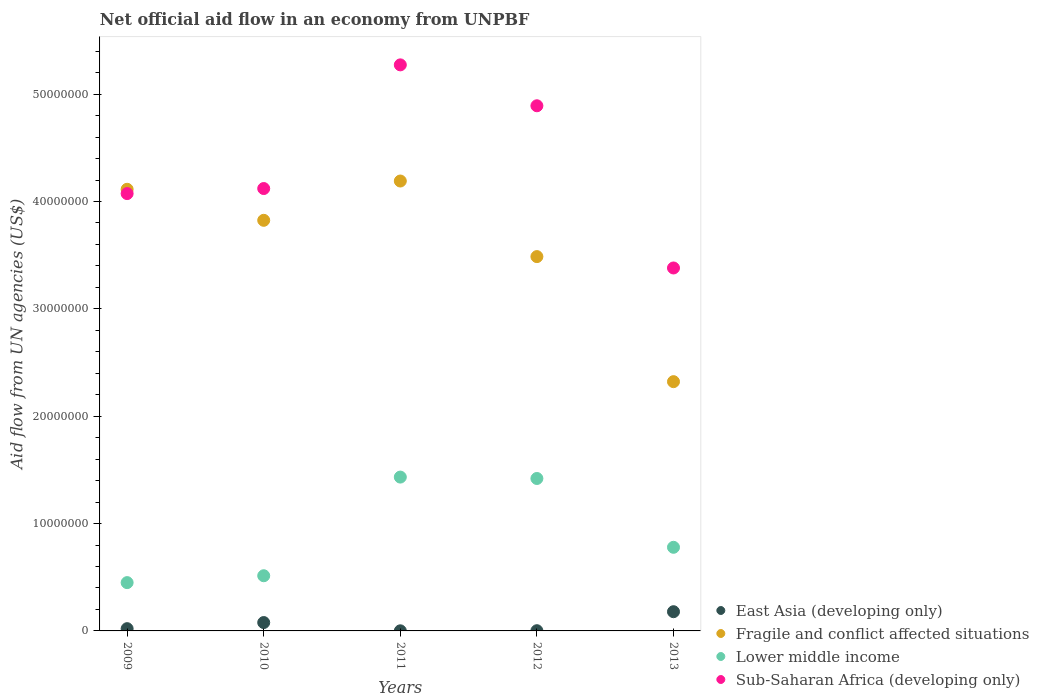How many different coloured dotlines are there?
Your answer should be very brief. 4. What is the net official aid flow in Sub-Saharan Africa (developing only) in 2011?
Your answer should be compact. 5.27e+07. Across all years, what is the maximum net official aid flow in Lower middle income?
Provide a succinct answer. 1.43e+07. Across all years, what is the minimum net official aid flow in Fragile and conflict affected situations?
Your answer should be compact. 2.32e+07. In which year was the net official aid flow in East Asia (developing only) maximum?
Offer a very short reply. 2013. In which year was the net official aid flow in Sub-Saharan Africa (developing only) minimum?
Make the answer very short. 2013. What is the total net official aid flow in Fragile and conflict affected situations in the graph?
Provide a succinct answer. 1.79e+08. What is the difference between the net official aid flow in Fragile and conflict affected situations in 2011 and that in 2013?
Give a very brief answer. 1.87e+07. What is the difference between the net official aid flow in Lower middle income in 2011 and the net official aid flow in Sub-Saharan Africa (developing only) in 2013?
Your response must be concise. -1.95e+07. What is the average net official aid flow in East Asia (developing only) per year?
Keep it short and to the point. 5.62e+05. In the year 2013, what is the difference between the net official aid flow in Fragile and conflict affected situations and net official aid flow in Lower middle income?
Provide a short and direct response. 1.54e+07. Is the difference between the net official aid flow in Fragile and conflict affected situations in 2011 and 2013 greater than the difference between the net official aid flow in Lower middle income in 2011 and 2013?
Provide a short and direct response. Yes. What is the difference between the highest and the second highest net official aid flow in Fragile and conflict affected situations?
Give a very brief answer. 7.70e+05. What is the difference between the highest and the lowest net official aid flow in East Asia (developing only)?
Provide a short and direct response. 1.78e+06. In how many years, is the net official aid flow in East Asia (developing only) greater than the average net official aid flow in East Asia (developing only) taken over all years?
Provide a succinct answer. 2. Does the net official aid flow in Lower middle income monotonically increase over the years?
Make the answer very short. No. Is the net official aid flow in East Asia (developing only) strictly greater than the net official aid flow in Fragile and conflict affected situations over the years?
Offer a very short reply. No. How many dotlines are there?
Make the answer very short. 4. How many years are there in the graph?
Keep it short and to the point. 5. What is the difference between two consecutive major ticks on the Y-axis?
Provide a succinct answer. 1.00e+07. Does the graph contain any zero values?
Your answer should be compact. No. How many legend labels are there?
Your answer should be very brief. 4. What is the title of the graph?
Keep it short and to the point. Net official aid flow in an economy from UNPBF. What is the label or title of the Y-axis?
Make the answer very short. Aid flow from UN agencies (US$). What is the Aid flow from UN agencies (US$) in East Asia (developing only) in 2009?
Give a very brief answer. 2.10e+05. What is the Aid flow from UN agencies (US$) of Fragile and conflict affected situations in 2009?
Offer a very short reply. 4.11e+07. What is the Aid flow from UN agencies (US$) in Lower middle income in 2009?
Ensure brevity in your answer.  4.50e+06. What is the Aid flow from UN agencies (US$) in Sub-Saharan Africa (developing only) in 2009?
Offer a terse response. 4.07e+07. What is the Aid flow from UN agencies (US$) of East Asia (developing only) in 2010?
Offer a very short reply. 7.80e+05. What is the Aid flow from UN agencies (US$) in Fragile and conflict affected situations in 2010?
Offer a terse response. 3.82e+07. What is the Aid flow from UN agencies (US$) of Lower middle income in 2010?
Provide a succinct answer. 5.14e+06. What is the Aid flow from UN agencies (US$) of Sub-Saharan Africa (developing only) in 2010?
Make the answer very short. 4.12e+07. What is the Aid flow from UN agencies (US$) in Fragile and conflict affected situations in 2011?
Provide a succinct answer. 4.19e+07. What is the Aid flow from UN agencies (US$) in Lower middle income in 2011?
Ensure brevity in your answer.  1.43e+07. What is the Aid flow from UN agencies (US$) of Sub-Saharan Africa (developing only) in 2011?
Give a very brief answer. 5.27e+07. What is the Aid flow from UN agencies (US$) of East Asia (developing only) in 2012?
Your answer should be compact. 2.00e+04. What is the Aid flow from UN agencies (US$) of Fragile and conflict affected situations in 2012?
Provide a succinct answer. 3.49e+07. What is the Aid flow from UN agencies (US$) in Lower middle income in 2012?
Offer a terse response. 1.42e+07. What is the Aid flow from UN agencies (US$) of Sub-Saharan Africa (developing only) in 2012?
Make the answer very short. 4.89e+07. What is the Aid flow from UN agencies (US$) of East Asia (developing only) in 2013?
Give a very brief answer. 1.79e+06. What is the Aid flow from UN agencies (US$) of Fragile and conflict affected situations in 2013?
Provide a short and direct response. 2.32e+07. What is the Aid flow from UN agencies (US$) of Lower middle income in 2013?
Your answer should be very brief. 7.79e+06. What is the Aid flow from UN agencies (US$) of Sub-Saharan Africa (developing only) in 2013?
Offer a very short reply. 3.38e+07. Across all years, what is the maximum Aid flow from UN agencies (US$) of East Asia (developing only)?
Your answer should be compact. 1.79e+06. Across all years, what is the maximum Aid flow from UN agencies (US$) of Fragile and conflict affected situations?
Your answer should be very brief. 4.19e+07. Across all years, what is the maximum Aid flow from UN agencies (US$) in Lower middle income?
Your answer should be compact. 1.43e+07. Across all years, what is the maximum Aid flow from UN agencies (US$) of Sub-Saharan Africa (developing only)?
Ensure brevity in your answer.  5.27e+07. Across all years, what is the minimum Aid flow from UN agencies (US$) in East Asia (developing only)?
Offer a terse response. 10000. Across all years, what is the minimum Aid flow from UN agencies (US$) of Fragile and conflict affected situations?
Make the answer very short. 2.32e+07. Across all years, what is the minimum Aid flow from UN agencies (US$) of Lower middle income?
Ensure brevity in your answer.  4.50e+06. Across all years, what is the minimum Aid flow from UN agencies (US$) of Sub-Saharan Africa (developing only)?
Provide a succinct answer. 3.38e+07. What is the total Aid flow from UN agencies (US$) in East Asia (developing only) in the graph?
Your answer should be very brief. 2.81e+06. What is the total Aid flow from UN agencies (US$) in Fragile and conflict affected situations in the graph?
Ensure brevity in your answer.  1.79e+08. What is the total Aid flow from UN agencies (US$) in Lower middle income in the graph?
Offer a very short reply. 4.60e+07. What is the total Aid flow from UN agencies (US$) of Sub-Saharan Africa (developing only) in the graph?
Make the answer very short. 2.17e+08. What is the difference between the Aid flow from UN agencies (US$) in East Asia (developing only) in 2009 and that in 2010?
Offer a very short reply. -5.70e+05. What is the difference between the Aid flow from UN agencies (US$) in Fragile and conflict affected situations in 2009 and that in 2010?
Your answer should be compact. 2.89e+06. What is the difference between the Aid flow from UN agencies (US$) of Lower middle income in 2009 and that in 2010?
Ensure brevity in your answer.  -6.40e+05. What is the difference between the Aid flow from UN agencies (US$) in Sub-Saharan Africa (developing only) in 2009 and that in 2010?
Your response must be concise. -4.70e+05. What is the difference between the Aid flow from UN agencies (US$) of Fragile and conflict affected situations in 2009 and that in 2011?
Your response must be concise. -7.70e+05. What is the difference between the Aid flow from UN agencies (US$) in Lower middle income in 2009 and that in 2011?
Provide a short and direct response. -9.83e+06. What is the difference between the Aid flow from UN agencies (US$) of Sub-Saharan Africa (developing only) in 2009 and that in 2011?
Provide a short and direct response. -1.20e+07. What is the difference between the Aid flow from UN agencies (US$) of East Asia (developing only) in 2009 and that in 2012?
Your answer should be compact. 1.90e+05. What is the difference between the Aid flow from UN agencies (US$) in Fragile and conflict affected situations in 2009 and that in 2012?
Make the answer very short. 6.27e+06. What is the difference between the Aid flow from UN agencies (US$) of Lower middle income in 2009 and that in 2012?
Keep it short and to the point. -9.70e+06. What is the difference between the Aid flow from UN agencies (US$) of Sub-Saharan Africa (developing only) in 2009 and that in 2012?
Offer a terse response. -8.18e+06. What is the difference between the Aid flow from UN agencies (US$) in East Asia (developing only) in 2009 and that in 2013?
Your answer should be very brief. -1.58e+06. What is the difference between the Aid flow from UN agencies (US$) in Fragile and conflict affected situations in 2009 and that in 2013?
Your response must be concise. 1.79e+07. What is the difference between the Aid flow from UN agencies (US$) in Lower middle income in 2009 and that in 2013?
Provide a succinct answer. -3.29e+06. What is the difference between the Aid flow from UN agencies (US$) in Sub-Saharan Africa (developing only) in 2009 and that in 2013?
Offer a very short reply. 6.93e+06. What is the difference between the Aid flow from UN agencies (US$) of East Asia (developing only) in 2010 and that in 2011?
Offer a terse response. 7.70e+05. What is the difference between the Aid flow from UN agencies (US$) of Fragile and conflict affected situations in 2010 and that in 2011?
Your response must be concise. -3.66e+06. What is the difference between the Aid flow from UN agencies (US$) in Lower middle income in 2010 and that in 2011?
Keep it short and to the point. -9.19e+06. What is the difference between the Aid flow from UN agencies (US$) in Sub-Saharan Africa (developing only) in 2010 and that in 2011?
Make the answer very short. -1.15e+07. What is the difference between the Aid flow from UN agencies (US$) in East Asia (developing only) in 2010 and that in 2012?
Make the answer very short. 7.60e+05. What is the difference between the Aid flow from UN agencies (US$) of Fragile and conflict affected situations in 2010 and that in 2012?
Give a very brief answer. 3.38e+06. What is the difference between the Aid flow from UN agencies (US$) of Lower middle income in 2010 and that in 2012?
Your answer should be compact. -9.06e+06. What is the difference between the Aid flow from UN agencies (US$) in Sub-Saharan Africa (developing only) in 2010 and that in 2012?
Keep it short and to the point. -7.71e+06. What is the difference between the Aid flow from UN agencies (US$) of East Asia (developing only) in 2010 and that in 2013?
Make the answer very short. -1.01e+06. What is the difference between the Aid flow from UN agencies (US$) in Fragile and conflict affected situations in 2010 and that in 2013?
Offer a terse response. 1.50e+07. What is the difference between the Aid flow from UN agencies (US$) in Lower middle income in 2010 and that in 2013?
Your answer should be compact. -2.65e+06. What is the difference between the Aid flow from UN agencies (US$) in Sub-Saharan Africa (developing only) in 2010 and that in 2013?
Your response must be concise. 7.40e+06. What is the difference between the Aid flow from UN agencies (US$) in East Asia (developing only) in 2011 and that in 2012?
Your answer should be compact. -10000. What is the difference between the Aid flow from UN agencies (US$) in Fragile and conflict affected situations in 2011 and that in 2012?
Give a very brief answer. 7.04e+06. What is the difference between the Aid flow from UN agencies (US$) of Sub-Saharan Africa (developing only) in 2011 and that in 2012?
Offer a very short reply. 3.81e+06. What is the difference between the Aid flow from UN agencies (US$) of East Asia (developing only) in 2011 and that in 2013?
Your answer should be compact. -1.78e+06. What is the difference between the Aid flow from UN agencies (US$) of Fragile and conflict affected situations in 2011 and that in 2013?
Make the answer very short. 1.87e+07. What is the difference between the Aid flow from UN agencies (US$) of Lower middle income in 2011 and that in 2013?
Your answer should be compact. 6.54e+06. What is the difference between the Aid flow from UN agencies (US$) of Sub-Saharan Africa (developing only) in 2011 and that in 2013?
Give a very brief answer. 1.89e+07. What is the difference between the Aid flow from UN agencies (US$) in East Asia (developing only) in 2012 and that in 2013?
Keep it short and to the point. -1.77e+06. What is the difference between the Aid flow from UN agencies (US$) in Fragile and conflict affected situations in 2012 and that in 2013?
Provide a succinct answer. 1.16e+07. What is the difference between the Aid flow from UN agencies (US$) in Lower middle income in 2012 and that in 2013?
Your answer should be compact. 6.41e+06. What is the difference between the Aid flow from UN agencies (US$) of Sub-Saharan Africa (developing only) in 2012 and that in 2013?
Your answer should be compact. 1.51e+07. What is the difference between the Aid flow from UN agencies (US$) of East Asia (developing only) in 2009 and the Aid flow from UN agencies (US$) of Fragile and conflict affected situations in 2010?
Give a very brief answer. -3.80e+07. What is the difference between the Aid flow from UN agencies (US$) in East Asia (developing only) in 2009 and the Aid flow from UN agencies (US$) in Lower middle income in 2010?
Make the answer very short. -4.93e+06. What is the difference between the Aid flow from UN agencies (US$) of East Asia (developing only) in 2009 and the Aid flow from UN agencies (US$) of Sub-Saharan Africa (developing only) in 2010?
Make the answer very short. -4.10e+07. What is the difference between the Aid flow from UN agencies (US$) of Fragile and conflict affected situations in 2009 and the Aid flow from UN agencies (US$) of Lower middle income in 2010?
Offer a terse response. 3.60e+07. What is the difference between the Aid flow from UN agencies (US$) of Fragile and conflict affected situations in 2009 and the Aid flow from UN agencies (US$) of Sub-Saharan Africa (developing only) in 2010?
Provide a short and direct response. -7.00e+04. What is the difference between the Aid flow from UN agencies (US$) in Lower middle income in 2009 and the Aid flow from UN agencies (US$) in Sub-Saharan Africa (developing only) in 2010?
Make the answer very short. -3.67e+07. What is the difference between the Aid flow from UN agencies (US$) in East Asia (developing only) in 2009 and the Aid flow from UN agencies (US$) in Fragile and conflict affected situations in 2011?
Your answer should be very brief. -4.17e+07. What is the difference between the Aid flow from UN agencies (US$) in East Asia (developing only) in 2009 and the Aid flow from UN agencies (US$) in Lower middle income in 2011?
Give a very brief answer. -1.41e+07. What is the difference between the Aid flow from UN agencies (US$) in East Asia (developing only) in 2009 and the Aid flow from UN agencies (US$) in Sub-Saharan Africa (developing only) in 2011?
Offer a terse response. -5.25e+07. What is the difference between the Aid flow from UN agencies (US$) of Fragile and conflict affected situations in 2009 and the Aid flow from UN agencies (US$) of Lower middle income in 2011?
Make the answer very short. 2.68e+07. What is the difference between the Aid flow from UN agencies (US$) of Fragile and conflict affected situations in 2009 and the Aid flow from UN agencies (US$) of Sub-Saharan Africa (developing only) in 2011?
Your answer should be compact. -1.16e+07. What is the difference between the Aid flow from UN agencies (US$) of Lower middle income in 2009 and the Aid flow from UN agencies (US$) of Sub-Saharan Africa (developing only) in 2011?
Give a very brief answer. -4.82e+07. What is the difference between the Aid flow from UN agencies (US$) in East Asia (developing only) in 2009 and the Aid flow from UN agencies (US$) in Fragile and conflict affected situations in 2012?
Provide a short and direct response. -3.47e+07. What is the difference between the Aid flow from UN agencies (US$) of East Asia (developing only) in 2009 and the Aid flow from UN agencies (US$) of Lower middle income in 2012?
Ensure brevity in your answer.  -1.40e+07. What is the difference between the Aid flow from UN agencies (US$) in East Asia (developing only) in 2009 and the Aid flow from UN agencies (US$) in Sub-Saharan Africa (developing only) in 2012?
Your answer should be very brief. -4.87e+07. What is the difference between the Aid flow from UN agencies (US$) in Fragile and conflict affected situations in 2009 and the Aid flow from UN agencies (US$) in Lower middle income in 2012?
Offer a terse response. 2.69e+07. What is the difference between the Aid flow from UN agencies (US$) in Fragile and conflict affected situations in 2009 and the Aid flow from UN agencies (US$) in Sub-Saharan Africa (developing only) in 2012?
Offer a very short reply. -7.78e+06. What is the difference between the Aid flow from UN agencies (US$) of Lower middle income in 2009 and the Aid flow from UN agencies (US$) of Sub-Saharan Africa (developing only) in 2012?
Make the answer very short. -4.44e+07. What is the difference between the Aid flow from UN agencies (US$) in East Asia (developing only) in 2009 and the Aid flow from UN agencies (US$) in Fragile and conflict affected situations in 2013?
Your answer should be compact. -2.30e+07. What is the difference between the Aid flow from UN agencies (US$) in East Asia (developing only) in 2009 and the Aid flow from UN agencies (US$) in Lower middle income in 2013?
Provide a short and direct response. -7.58e+06. What is the difference between the Aid flow from UN agencies (US$) in East Asia (developing only) in 2009 and the Aid flow from UN agencies (US$) in Sub-Saharan Africa (developing only) in 2013?
Offer a very short reply. -3.36e+07. What is the difference between the Aid flow from UN agencies (US$) in Fragile and conflict affected situations in 2009 and the Aid flow from UN agencies (US$) in Lower middle income in 2013?
Offer a terse response. 3.34e+07. What is the difference between the Aid flow from UN agencies (US$) of Fragile and conflict affected situations in 2009 and the Aid flow from UN agencies (US$) of Sub-Saharan Africa (developing only) in 2013?
Ensure brevity in your answer.  7.33e+06. What is the difference between the Aid flow from UN agencies (US$) of Lower middle income in 2009 and the Aid flow from UN agencies (US$) of Sub-Saharan Africa (developing only) in 2013?
Keep it short and to the point. -2.93e+07. What is the difference between the Aid flow from UN agencies (US$) of East Asia (developing only) in 2010 and the Aid flow from UN agencies (US$) of Fragile and conflict affected situations in 2011?
Keep it short and to the point. -4.11e+07. What is the difference between the Aid flow from UN agencies (US$) of East Asia (developing only) in 2010 and the Aid flow from UN agencies (US$) of Lower middle income in 2011?
Offer a very short reply. -1.36e+07. What is the difference between the Aid flow from UN agencies (US$) of East Asia (developing only) in 2010 and the Aid flow from UN agencies (US$) of Sub-Saharan Africa (developing only) in 2011?
Your answer should be very brief. -5.20e+07. What is the difference between the Aid flow from UN agencies (US$) in Fragile and conflict affected situations in 2010 and the Aid flow from UN agencies (US$) in Lower middle income in 2011?
Give a very brief answer. 2.39e+07. What is the difference between the Aid flow from UN agencies (US$) of Fragile and conflict affected situations in 2010 and the Aid flow from UN agencies (US$) of Sub-Saharan Africa (developing only) in 2011?
Give a very brief answer. -1.45e+07. What is the difference between the Aid flow from UN agencies (US$) in Lower middle income in 2010 and the Aid flow from UN agencies (US$) in Sub-Saharan Africa (developing only) in 2011?
Give a very brief answer. -4.76e+07. What is the difference between the Aid flow from UN agencies (US$) of East Asia (developing only) in 2010 and the Aid flow from UN agencies (US$) of Fragile and conflict affected situations in 2012?
Your answer should be compact. -3.41e+07. What is the difference between the Aid flow from UN agencies (US$) of East Asia (developing only) in 2010 and the Aid flow from UN agencies (US$) of Lower middle income in 2012?
Offer a terse response. -1.34e+07. What is the difference between the Aid flow from UN agencies (US$) of East Asia (developing only) in 2010 and the Aid flow from UN agencies (US$) of Sub-Saharan Africa (developing only) in 2012?
Ensure brevity in your answer.  -4.81e+07. What is the difference between the Aid flow from UN agencies (US$) in Fragile and conflict affected situations in 2010 and the Aid flow from UN agencies (US$) in Lower middle income in 2012?
Offer a terse response. 2.40e+07. What is the difference between the Aid flow from UN agencies (US$) of Fragile and conflict affected situations in 2010 and the Aid flow from UN agencies (US$) of Sub-Saharan Africa (developing only) in 2012?
Provide a succinct answer. -1.07e+07. What is the difference between the Aid flow from UN agencies (US$) in Lower middle income in 2010 and the Aid flow from UN agencies (US$) in Sub-Saharan Africa (developing only) in 2012?
Your answer should be very brief. -4.38e+07. What is the difference between the Aid flow from UN agencies (US$) of East Asia (developing only) in 2010 and the Aid flow from UN agencies (US$) of Fragile and conflict affected situations in 2013?
Offer a terse response. -2.24e+07. What is the difference between the Aid flow from UN agencies (US$) in East Asia (developing only) in 2010 and the Aid flow from UN agencies (US$) in Lower middle income in 2013?
Your answer should be very brief. -7.01e+06. What is the difference between the Aid flow from UN agencies (US$) in East Asia (developing only) in 2010 and the Aid flow from UN agencies (US$) in Sub-Saharan Africa (developing only) in 2013?
Keep it short and to the point. -3.30e+07. What is the difference between the Aid flow from UN agencies (US$) in Fragile and conflict affected situations in 2010 and the Aid flow from UN agencies (US$) in Lower middle income in 2013?
Your response must be concise. 3.05e+07. What is the difference between the Aid flow from UN agencies (US$) of Fragile and conflict affected situations in 2010 and the Aid flow from UN agencies (US$) of Sub-Saharan Africa (developing only) in 2013?
Offer a very short reply. 4.44e+06. What is the difference between the Aid flow from UN agencies (US$) of Lower middle income in 2010 and the Aid flow from UN agencies (US$) of Sub-Saharan Africa (developing only) in 2013?
Make the answer very short. -2.87e+07. What is the difference between the Aid flow from UN agencies (US$) in East Asia (developing only) in 2011 and the Aid flow from UN agencies (US$) in Fragile and conflict affected situations in 2012?
Offer a very short reply. -3.49e+07. What is the difference between the Aid flow from UN agencies (US$) of East Asia (developing only) in 2011 and the Aid flow from UN agencies (US$) of Lower middle income in 2012?
Offer a terse response. -1.42e+07. What is the difference between the Aid flow from UN agencies (US$) in East Asia (developing only) in 2011 and the Aid flow from UN agencies (US$) in Sub-Saharan Africa (developing only) in 2012?
Offer a terse response. -4.89e+07. What is the difference between the Aid flow from UN agencies (US$) in Fragile and conflict affected situations in 2011 and the Aid flow from UN agencies (US$) in Lower middle income in 2012?
Offer a very short reply. 2.77e+07. What is the difference between the Aid flow from UN agencies (US$) of Fragile and conflict affected situations in 2011 and the Aid flow from UN agencies (US$) of Sub-Saharan Africa (developing only) in 2012?
Offer a very short reply. -7.01e+06. What is the difference between the Aid flow from UN agencies (US$) in Lower middle income in 2011 and the Aid flow from UN agencies (US$) in Sub-Saharan Africa (developing only) in 2012?
Your response must be concise. -3.46e+07. What is the difference between the Aid flow from UN agencies (US$) in East Asia (developing only) in 2011 and the Aid flow from UN agencies (US$) in Fragile and conflict affected situations in 2013?
Your answer should be very brief. -2.32e+07. What is the difference between the Aid flow from UN agencies (US$) in East Asia (developing only) in 2011 and the Aid flow from UN agencies (US$) in Lower middle income in 2013?
Give a very brief answer. -7.78e+06. What is the difference between the Aid flow from UN agencies (US$) in East Asia (developing only) in 2011 and the Aid flow from UN agencies (US$) in Sub-Saharan Africa (developing only) in 2013?
Offer a very short reply. -3.38e+07. What is the difference between the Aid flow from UN agencies (US$) of Fragile and conflict affected situations in 2011 and the Aid flow from UN agencies (US$) of Lower middle income in 2013?
Ensure brevity in your answer.  3.41e+07. What is the difference between the Aid flow from UN agencies (US$) in Fragile and conflict affected situations in 2011 and the Aid flow from UN agencies (US$) in Sub-Saharan Africa (developing only) in 2013?
Offer a very short reply. 8.10e+06. What is the difference between the Aid flow from UN agencies (US$) in Lower middle income in 2011 and the Aid flow from UN agencies (US$) in Sub-Saharan Africa (developing only) in 2013?
Offer a terse response. -1.95e+07. What is the difference between the Aid flow from UN agencies (US$) of East Asia (developing only) in 2012 and the Aid flow from UN agencies (US$) of Fragile and conflict affected situations in 2013?
Provide a succinct answer. -2.32e+07. What is the difference between the Aid flow from UN agencies (US$) of East Asia (developing only) in 2012 and the Aid flow from UN agencies (US$) of Lower middle income in 2013?
Provide a succinct answer. -7.77e+06. What is the difference between the Aid flow from UN agencies (US$) in East Asia (developing only) in 2012 and the Aid flow from UN agencies (US$) in Sub-Saharan Africa (developing only) in 2013?
Give a very brief answer. -3.38e+07. What is the difference between the Aid flow from UN agencies (US$) of Fragile and conflict affected situations in 2012 and the Aid flow from UN agencies (US$) of Lower middle income in 2013?
Your answer should be very brief. 2.71e+07. What is the difference between the Aid flow from UN agencies (US$) of Fragile and conflict affected situations in 2012 and the Aid flow from UN agencies (US$) of Sub-Saharan Africa (developing only) in 2013?
Make the answer very short. 1.06e+06. What is the difference between the Aid flow from UN agencies (US$) of Lower middle income in 2012 and the Aid flow from UN agencies (US$) of Sub-Saharan Africa (developing only) in 2013?
Offer a very short reply. -1.96e+07. What is the average Aid flow from UN agencies (US$) of East Asia (developing only) per year?
Provide a succinct answer. 5.62e+05. What is the average Aid flow from UN agencies (US$) of Fragile and conflict affected situations per year?
Your answer should be compact. 3.59e+07. What is the average Aid flow from UN agencies (US$) of Lower middle income per year?
Provide a short and direct response. 9.19e+06. What is the average Aid flow from UN agencies (US$) in Sub-Saharan Africa (developing only) per year?
Give a very brief answer. 4.35e+07. In the year 2009, what is the difference between the Aid flow from UN agencies (US$) in East Asia (developing only) and Aid flow from UN agencies (US$) in Fragile and conflict affected situations?
Offer a very short reply. -4.09e+07. In the year 2009, what is the difference between the Aid flow from UN agencies (US$) of East Asia (developing only) and Aid flow from UN agencies (US$) of Lower middle income?
Provide a short and direct response. -4.29e+06. In the year 2009, what is the difference between the Aid flow from UN agencies (US$) in East Asia (developing only) and Aid flow from UN agencies (US$) in Sub-Saharan Africa (developing only)?
Give a very brief answer. -4.05e+07. In the year 2009, what is the difference between the Aid flow from UN agencies (US$) of Fragile and conflict affected situations and Aid flow from UN agencies (US$) of Lower middle income?
Provide a short and direct response. 3.66e+07. In the year 2009, what is the difference between the Aid flow from UN agencies (US$) of Fragile and conflict affected situations and Aid flow from UN agencies (US$) of Sub-Saharan Africa (developing only)?
Make the answer very short. 4.00e+05. In the year 2009, what is the difference between the Aid flow from UN agencies (US$) in Lower middle income and Aid flow from UN agencies (US$) in Sub-Saharan Africa (developing only)?
Your answer should be very brief. -3.62e+07. In the year 2010, what is the difference between the Aid flow from UN agencies (US$) of East Asia (developing only) and Aid flow from UN agencies (US$) of Fragile and conflict affected situations?
Provide a succinct answer. -3.75e+07. In the year 2010, what is the difference between the Aid flow from UN agencies (US$) of East Asia (developing only) and Aid flow from UN agencies (US$) of Lower middle income?
Give a very brief answer. -4.36e+06. In the year 2010, what is the difference between the Aid flow from UN agencies (US$) in East Asia (developing only) and Aid flow from UN agencies (US$) in Sub-Saharan Africa (developing only)?
Keep it short and to the point. -4.04e+07. In the year 2010, what is the difference between the Aid flow from UN agencies (US$) in Fragile and conflict affected situations and Aid flow from UN agencies (US$) in Lower middle income?
Your answer should be very brief. 3.31e+07. In the year 2010, what is the difference between the Aid flow from UN agencies (US$) of Fragile and conflict affected situations and Aid flow from UN agencies (US$) of Sub-Saharan Africa (developing only)?
Offer a terse response. -2.96e+06. In the year 2010, what is the difference between the Aid flow from UN agencies (US$) of Lower middle income and Aid flow from UN agencies (US$) of Sub-Saharan Africa (developing only)?
Offer a terse response. -3.61e+07. In the year 2011, what is the difference between the Aid flow from UN agencies (US$) in East Asia (developing only) and Aid flow from UN agencies (US$) in Fragile and conflict affected situations?
Your response must be concise. -4.19e+07. In the year 2011, what is the difference between the Aid flow from UN agencies (US$) of East Asia (developing only) and Aid flow from UN agencies (US$) of Lower middle income?
Make the answer very short. -1.43e+07. In the year 2011, what is the difference between the Aid flow from UN agencies (US$) in East Asia (developing only) and Aid flow from UN agencies (US$) in Sub-Saharan Africa (developing only)?
Offer a very short reply. -5.27e+07. In the year 2011, what is the difference between the Aid flow from UN agencies (US$) of Fragile and conflict affected situations and Aid flow from UN agencies (US$) of Lower middle income?
Give a very brief answer. 2.76e+07. In the year 2011, what is the difference between the Aid flow from UN agencies (US$) of Fragile and conflict affected situations and Aid flow from UN agencies (US$) of Sub-Saharan Africa (developing only)?
Your answer should be very brief. -1.08e+07. In the year 2011, what is the difference between the Aid flow from UN agencies (US$) of Lower middle income and Aid flow from UN agencies (US$) of Sub-Saharan Africa (developing only)?
Provide a short and direct response. -3.84e+07. In the year 2012, what is the difference between the Aid flow from UN agencies (US$) in East Asia (developing only) and Aid flow from UN agencies (US$) in Fragile and conflict affected situations?
Offer a very short reply. -3.48e+07. In the year 2012, what is the difference between the Aid flow from UN agencies (US$) of East Asia (developing only) and Aid flow from UN agencies (US$) of Lower middle income?
Your response must be concise. -1.42e+07. In the year 2012, what is the difference between the Aid flow from UN agencies (US$) in East Asia (developing only) and Aid flow from UN agencies (US$) in Sub-Saharan Africa (developing only)?
Offer a terse response. -4.89e+07. In the year 2012, what is the difference between the Aid flow from UN agencies (US$) of Fragile and conflict affected situations and Aid flow from UN agencies (US$) of Lower middle income?
Give a very brief answer. 2.07e+07. In the year 2012, what is the difference between the Aid flow from UN agencies (US$) of Fragile and conflict affected situations and Aid flow from UN agencies (US$) of Sub-Saharan Africa (developing only)?
Provide a short and direct response. -1.40e+07. In the year 2012, what is the difference between the Aid flow from UN agencies (US$) in Lower middle income and Aid flow from UN agencies (US$) in Sub-Saharan Africa (developing only)?
Provide a succinct answer. -3.47e+07. In the year 2013, what is the difference between the Aid flow from UN agencies (US$) in East Asia (developing only) and Aid flow from UN agencies (US$) in Fragile and conflict affected situations?
Offer a very short reply. -2.14e+07. In the year 2013, what is the difference between the Aid flow from UN agencies (US$) in East Asia (developing only) and Aid flow from UN agencies (US$) in Lower middle income?
Ensure brevity in your answer.  -6.00e+06. In the year 2013, what is the difference between the Aid flow from UN agencies (US$) of East Asia (developing only) and Aid flow from UN agencies (US$) of Sub-Saharan Africa (developing only)?
Ensure brevity in your answer.  -3.20e+07. In the year 2013, what is the difference between the Aid flow from UN agencies (US$) of Fragile and conflict affected situations and Aid flow from UN agencies (US$) of Lower middle income?
Provide a succinct answer. 1.54e+07. In the year 2013, what is the difference between the Aid flow from UN agencies (US$) of Fragile and conflict affected situations and Aid flow from UN agencies (US$) of Sub-Saharan Africa (developing only)?
Provide a succinct answer. -1.06e+07. In the year 2013, what is the difference between the Aid flow from UN agencies (US$) in Lower middle income and Aid flow from UN agencies (US$) in Sub-Saharan Africa (developing only)?
Provide a short and direct response. -2.60e+07. What is the ratio of the Aid flow from UN agencies (US$) in East Asia (developing only) in 2009 to that in 2010?
Ensure brevity in your answer.  0.27. What is the ratio of the Aid flow from UN agencies (US$) of Fragile and conflict affected situations in 2009 to that in 2010?
Offer a terse response. 1.08. What is the ratio of the Aid flow from UN agencies (US$) of Lower middle income in 2009 to that in 2010?
Provide a succinct answer. 0.88. What is the ratio of the Aid flow from UN agencies (US$) of Sub-Saharan Africa (developing only) in 2009 to that in 2010?
Make the answer very short. 0.99. What is the ratio of the Aid flow from UN agencies (US$) of Fragile and conflict affected situations in 2009 to that in 2011?
Your answer should be compact. 0.98. What is the ratio of the Aid flow from UN agencies (US$) in Lower middle income in 2009 to that in 2011?
Give a very brief answer. 0.31. What is the ratio of the Aid flow from UN agencies (US$) of Sub-Saharan Africa (developing only) in 2009 to that in 2011?
Make the answer very short. 0.77. What is the ratio of the Aid flow from UN agencies (US$) in East Asia (developing only) in 2009 to that in 2012?
Offer a terse response. 10.5. What is the ratio of the Aid flow from UN agencies (US$) in Fragile and conflict affected situations in 2009 to that in 2012?
Your response must be concise. 1.18. What is the ratio of the Aid flow from UN agencies (US$) in Lower middle income in 2009 to that in 2012?
Keep it short and to the point. 0.32. What is the ratio of the Aid flow from UN agencies (US$) in Sub-Saharan Africa (developing only) in 2009 to that in 2012?
Give a very brief answer. 0.83. What is the ratio of the Aid flow from UN agencies (US$) in East Asia (developing only) in 2009 to that in 2013?
Your response must be concise. 0.12. What is the ratio of the Aid flow from UN agencies (US$) of Fragile and conflict affected situations in 2009 to that in 2013?
Offer a very short reply. 1.77. What is the ratio of the Aid flow from UN agencies (US$) of Lower middle income in 2009 to that in 2013?
Provide a short and direct response. 0.58. What is the ratio of the Aid flow from UN agencies (US$) of Sub-Saharan Africa (developing only) in 2009 to that in 2013?
Provide a succinct answer. 1.21. What is the ratio of the Aid flow from UN agencies (US$) of Fragile and conflict affected situations in 2010 to that in 2011?
Your answer should be compact. 0.91. What is the ratio of the Aid flow from UN agencies (US$) in Lower middle income in 2010 to that in 2011?
Provide a succinct answer. 0.36. What is the ratio of the Aid flow from UN agencies (US$) of Sub-Saharan Africa (developing only) in 2010 to that in 2011?
Your answer should be very brief. 0.78. What is the ratio of the Aid flow from UN agencies (US$) of East Asia (developing only) in 2010 to that in 2012?
Your response must be concise. 39. What is the ratio of the Aid flow from UN agencies (US$) in Fragile and conflict affected situations in 2010 to that in 2012?
Your answer should be very brief. 1.1. What is the ratio of the Aid flow from UN agencies (US$) in Lower middle income in 2010 to that in 2012?
Make the answer very short. 0.36. What is the ratio of the Aid flow from UN agencies (US$) of Sub-Saharan Africa (developing only) in 2010 to that in 2012?
Give a very brief answer. 0.84. What is the ratio of the Aid flow from UN agencies (US$) of East Asia (developing only) in 2010 to that in 2013?
Your answer should be compact. 0.44. What is the ratio of the Aid flow from UN agencies (US$) of Fragile and conflict affected situations in 2010 to that in 2013?
Keep it short and to the point. 1.65. What is the ratio of the Aid flow from UN agencies (US$) of Lower middle income in 2010 to that in 2013?
Give a very brief answer. 0.66. What is the ratio of the Aid flow from UN agencies (US$) of Sub-Saharan Africa (developing only) in 2010 to that in 2013?
Offer a terse response. 1.22. What is the ratio of the Aid flow from UN agencies (US$) of East Asia (developing only) in 2011 to that in 2012?
Offer a terse response. 0.5. What is the ratio of the Aid flow from UN agencies (US$) in Fragile and conflict affected situations in 2011 to that in 2012?
Your response must be concise. 1.2. What is the ratio of the Aid flow from UN agencies (US$) of Lower middle income in 2011 to that in 2012?
Give a very brief answer. 1.01. What is the ratio of the Aid flow from UN agencies (US$) of Sub-Saharan Africa (developing only) in 2011 to that in 2012?
Give a very brief answer. 1.08. What is the ratio of the Aid flow from UN agencies (US$) of East Asia (developing only) in 2011 to that in 2013?
Offer a very short reply. 0.01. What is the ratio of the Aid flow from UN agencies (US$) in Fragile and conflict affected situations in 2011 to that in 2013?
Offer a terse response. 1.8. What is the ratio of the Aid flow from UN agencies (US$) of Lower middle income in 2011 to that in 2013?
Provide a short and direct response. 1.84. What is the ratio of the Aid flow from UN agencies (US$) in Sub-Saharan Africa (developing only) in 2011 to that in 2013?
Your response must be concise. 1.56. What is the ratio of the Aid flow from UN agencies (US$) of East Asia (developing only) in 2012 to that in 2013?
Ensure brevity in your answer.  0.01. What is the ratio of the Aid flow from UN agencies (US$) of Fragile and conflict affected situations in 2012 to that in 2013?
Give a very brief answer. 1.5. What is the ratio of the Aid flow from UN agencies (US$) of Lower middle income in 2012 to that in 2013?
Your response must be concise. 1.82. What is the ratio of the Aid flow from UN agencies (US$) of Sub-Saharan Africa (developing only) in 2012 to that in 2013?
Make the answer very short. 1.45. What is the difference between the highest and the second highest Aid flow from UN agencies (US$) in East Asia (developing only)?
Keep it short and to the point. 1.01e+06. What is the difference between the highest and the second highest Aid flow from UN agencies (US$) in Fragile and conflict affected situations?
Give a very brief answer. 7.70e+05. What is the difference between the highest and the second highest Aid flow from UN agencies (US$) in Sub-Saharan Africa (developing only)?
Ensure brevity in your answer.  3.81e+06. What is the difference between the highest and the lowest Aid flow from UN agencies (US$) in East Asia (developing only)?
Provide a short and direct response. 1.78e+06. What is the difference between the highest and the lowest Aid flow from UN agencies (US$) in Fragile and conflict affected situations?
Give a very brief answer. 1.87e+07. What is the difference between the highest and the lowest Aid flow from UN agencies (US$) in Lower middle income?
Your response must be concise. 9.83e+06. What is the difference between the highest and the lowest Aid flow from UN agencies (US$) in Sub-Saharan Africa (developing only)?
Offer a very short reply. 1.89e+07. 